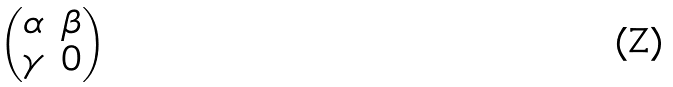Convert formula to latex. <formula><loc_0><loc_0><loc_500><loc_500>\begin{pmatrix} \alpha & \beta \\ \gamma & 0 \end{pmatrix}</formula> 